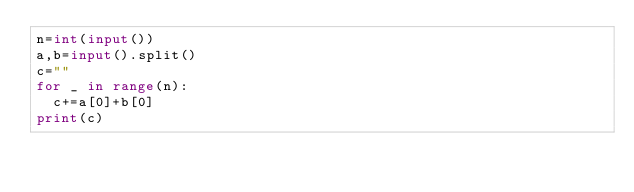<code> <loc_0><loc_0><loc_500><loc_500><_Python_>n=int(input())
a,b=input().split()
c=""
for _ in range(n):
  c+=a[0]+b[0]
print(c)</code> 